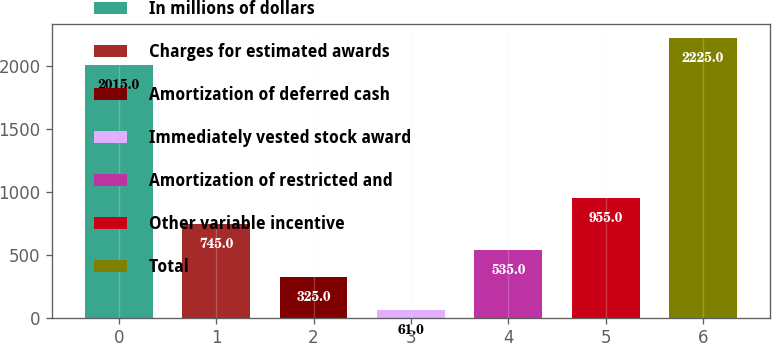Convert chart to OTSL. <chart><loc_0><loc_0><loc_500><loc_500><bar_chart><fcel>In millions of dollars<fcel>Charges for estimated awards<fcel>Amortization of deferred cash<fcel>Immediately vested stock award<fcel>Amortization of restricted and<fcel>Other variable incentive<fcel>Total<nl><fcel>2015<fcel>745<fcel>325<fcel>61<fcel>535<fcel>955<fcel>2225<nl></chart> 